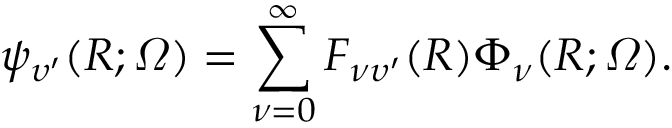<formula> <loc_0><loc_0><loc_500><loc_500>\psi _ { \upsilon ^ { \prime } } ( R ; \varOmega ) = \sum _ { \nu = 0 } ^ { \infty } F _ { \nu \upsilon ^ { \prime } } ( R ) \Phi _ { \nu } ( R ; \varOmega ) .</formula> 